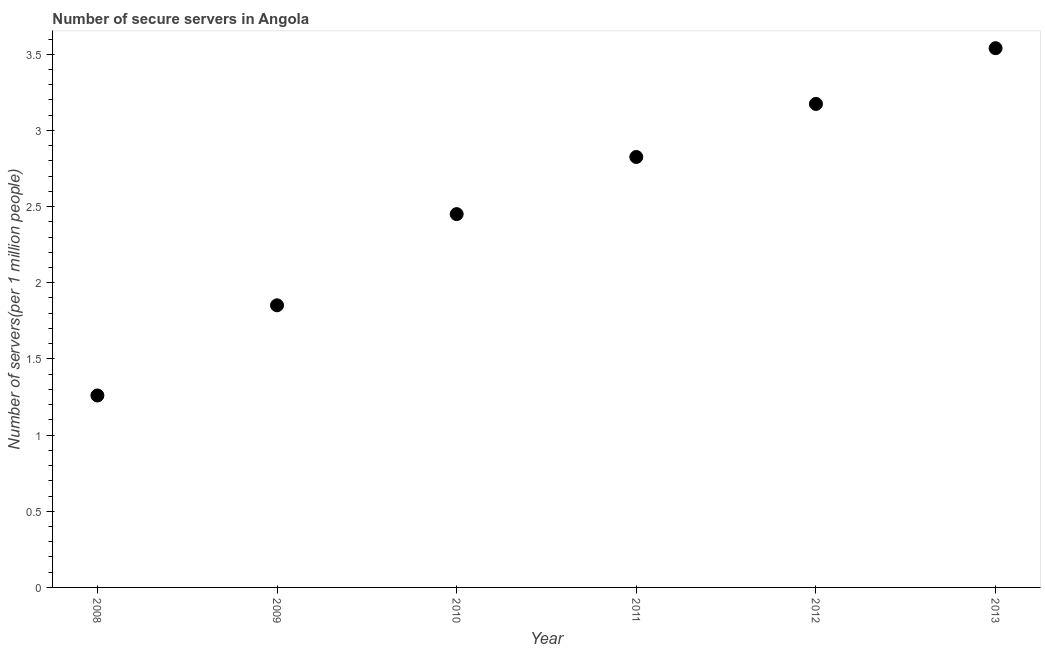What is the number of secure internet servers in 2012?
Keep it short and to the point. 3.17. Across all years, what is the maximum number of secure internet servers?
Offer a very short reply. 3.54. Across all years, what is the minimum number of secure internet servers?
Provide a succinct answer. 1.26. In which year was the number of secure internet servers minimum?
Provide a short and direct response. 2008. What is the sum of the number of secure internet servers?
Your response must be concise. 15.1. What is the difference between the number of secure internet servers in 2010 and 2011?
Offer a terse response. -0.38. What is the average number of secure internet servers per year?
Provide a short and direct response. 2.52. What is the median number of secure internet servers?
Your response must be concise. 2.64. What is the ratio of the number of secure internet servers in 2008 to that in 2009?
Keep it short and to the point. 0.68. Is the number of secure internet servers in 2012 less than that in 2013?
Offer a very short reply. Yes. What is the difference between the highest and the second highest number of secure internet servers?
Offer a terse response. 0.37. What is the difference between the highest and the lowest number of secure internet servers?
Your answer should be compact. 2.28. Does the graph contain any zero values?
Your answer should be very brief. No. What is the title of the graph?
Offer a very short reply. Number of secure servers in Angola. What is the label or title of the X-axis?
Ensure brevity in your answer.  Year. What is the label or title of the Y-axis?
Provide a succinct answer. Number of servers(per 1 million people). What is the Number of servers(per 1 million people) in 2008?
Give a very brief answer. 1.26. What is the Number of servers(per 1 million people) in 2009?
Your response must be concise. 1.85. What is the Number of servers(per 1 million people) in 2010?
Your answer should be very brief. 2.45. What is the Number of servers(per 1 million people) in 2011?
Your response must be concise. 2.83. What is the Number of servers(per 1 million people) in 2012?
Your response must be concise. 3.17. What is the Number of servers(per 1 million people) in 2013?
Offer a very short reply. 3.54. What is the difference between the Number of servers(per 1 million people) in 2008 and 2009?
Your answer should be very brief. -0.59. What is the difference between the Number of servers(per 1 million people) in 2008 and 2010?
Offer a terse response. -1.19. What is the difference between the Number of servers(per 1 million people) in 2008 and 2011?
Offer a terse response. -1.57. What is the difference between the Number of servers(per 1 million people) in 2008 and 2012?
Your answer should be compact. -1.91. What is the difference between the Number of servers(per 1 million people) in 2008 and 2013?
Your answer should be very brief. -2.28. What is the difference between the Number of servers(per 1 million people) in 2009 and 2010?
Provide a succinct answer. -0.6. What is the difference between the Number of servers(per 1 million people) in 2009 and 2011?
Ensure brevity in your answer.  -0.97. What is the difference between the Number of servers(per 1 million people) in 2009 and 2012?
Ensure brevity in your answer.  -1.32. What is the difference between the Number of servers(per 1 million people) in 2009 and 2013?
Offer a terse response. -1.69. What is the difference between the Number of servers(per 1 million people) in 2010 and 2011?
Give a very brief answer. -0.38. What is the difference between the Number of servers(per 1 million people) in 2010 and 2012?
Offer a very short reply. -0.72. What is the difference between the Number of servers(per 1 million people) in 2010 and 2013?
Keep it short and to the point. -1.09. What is the difference between the Number of servers(per 1 million people) in 2011 and 2012?
Make the answer very short. -0.35. What is the difference between the Number of servers(per 1 million people) in 2011 and 2013?
Give a very brief answer. -0.71. What is the difference between the Number of servers(per 1 million people) in 2012 and 2013?
Make the answer very short. -0.37. What is the ratio of the Number of servers(per 1 million people) in 2008 to that in 2009?
Offer a very short reply. 0.68. What is the ratio of the Number of servers(per 1 million people) in 2008 to that in 2010?
Your answer should be very brief. 0.51. What is the ratio of the Number of servers(per 1 million people) in 2008 to that in 2011?
Give a very brief answer. 0.45. What is the ratio of the Number of servers(per 1 million people) in 2008 to that in 2012?
Make the answer very short. 0.4. What is the ratio of the Number of servers(per 1 million people) in 2008 to that in 2013?
Your response must be concise. 0.36. What is the ratio of the Number of servers(per 1 million people) in 2009 to that in 2010?
Keep it short and to the point. 0.76. What is the ratio of the Number of servers(per 1 million people) in 2009 to that in 2011?
Offer a terse response. 0.66. What is the ratio of the Number of servers(per 1 million people) in 2009 to that in 2012?
Your answer should be very brief. 0.58. What is the ratio of the Number of servers(per 1 million people) in 2009 to that in 2013?
Ensure brevity in your answer.  0.52. What is the ratio of the Number of servers(per 1 million people) in 2010 to that in 2011?
Your answer should be compact. 0.87. What is the ratio of the Number of servers(per 1 million people) in 2010 to that in 2012?
Give a very brief answer. 0.77. What is the ratio of the Number of servers(per 1 million people) in 2010 to that in 2013?
Give a very brief answer. 0.69. What is the ratio of the Number of servers(per 1 million people) in 2011 to that in 2012?
Provide a short and direct response. 0.89. What is the ratio of the Number of servers(per 1 million people) in 2011 to that in 2013?
Provide a short and direct response. 0.8. What is the ratio of the Number of servers(per 1 million people) in 2012 to that in 2013?
Your answer should be compact. 0.9. 